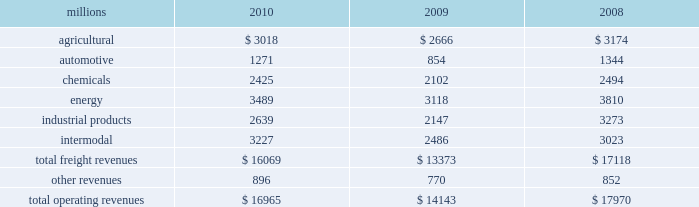Notes to the consolidated financial statements union pacific corporation and subsidiary companies for purposes of this report , unless the context otherwise requires , all references herein to the 201ccorporation 201d , 201cupc 201d , 201cwe 201d , 201cus 201d , and 201cour 201d mean union pacific corporation and its subsidiaries , including union pacific railroad company , which will be separately referred to herein as 201cuprr 201d or the 201crailroad 201d .
Nature of operations operations and segmentation 2013 we are a class i railroad that operates in the u.s .
We have 31953 route miles , linking pacific coast and gulf coast ports with the midwest and eastern u.s .
Gateways and providing several corridors to key mexican gateways .
We serve the western two-thirds of the country and maintain coordinated schedules with other rail carriers for the handling of freight to and from the atlantic coast , the pacific coast , the southeast , the southwest , canada , and mexico .
Export and import traffic is moved through gulf coast and pacific coast ports and across the mexican and canadian borders .
The railroad , along with its subsidiaries and rail affiliates , is our one reportable operating segment .
Although revenues are analyzed by commodity group , we analyze the net financial results of the railroad as one segment due to the integrated nature of our rail network .
The table provides revenue by commodity group : millions 2010 2009 2008 .
Although our revenues are principally derived from customers domiciled in the u.s. , the ultimate points of origination or destination for some products transported are outside the u.s .
Basis of presentation 2013 the consolidated financial statements are presented in accordance with accounting principles generally accepted in the u.s .
( gaap ) as codified in the financial accounting standards board ( fasb ) accounting standards codification ( asc ) .
Significant accounting policies principles of consolidation 2013 the consolidated financial statements include the accounts of union pacific corporation and all of its subsidiaries .
Investments in affiliated companies ( 20% ( 20 % ) to 50% ( 50 % ) owned ) are accounted for using the equity method of accounting .
All intercompany transactions are eliminated .
We currently have no less than majority-owned investments that require consolidation under variable interest entity requirements .
Cash and cash equivalents 2013 cash equivalents consist of investments with original maturities of three months or less .
Accounts receivable 2013 accounts receivable includes receivables reduced by an allowance for doubtful accounts .
The allowance is based upon historical losses , credit worthiness of customers , and current economic conditions .
Receivables not expected to be collected in one year and the associated allowances are classified as other assets in our consolidated statements of financial position .
Investments 2013 investments represent our investments in affiliated companies ( 20% ( 20 % ) to 50% ( 50 % ) owned ) that are accounted for under the equity method of accounting and investments in companies ( less than 20% ( 20 % ) owned ) accounted for under the cost method of accounting. .
In 2010 what was the total revenues per mile? 
Computations: (16965 / 31953)
Answer: 0.53094. 